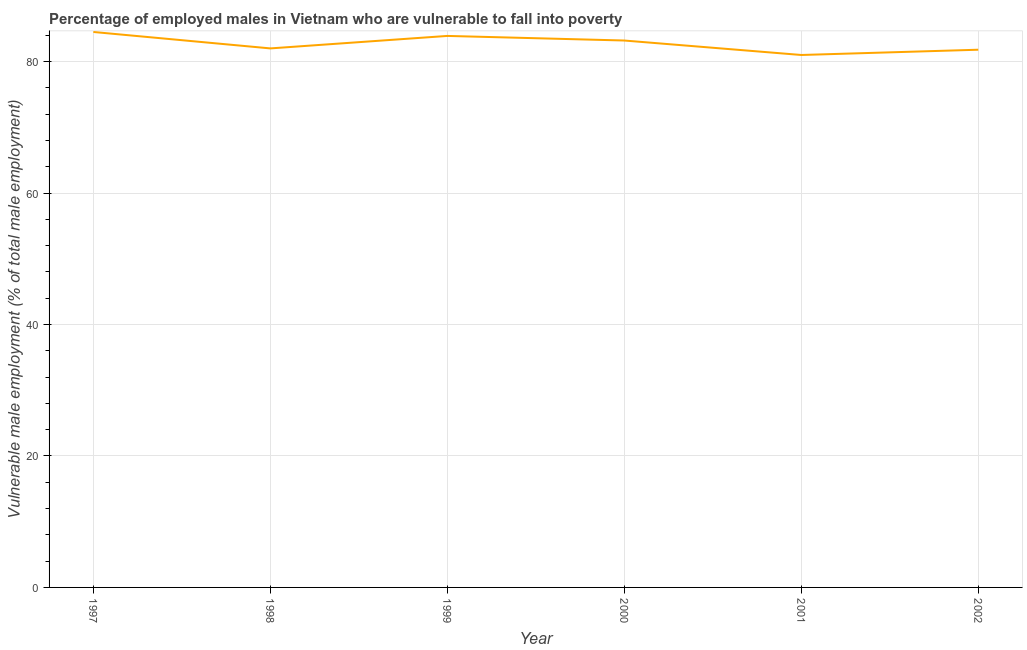What is the percentage of employed males who are vulnerable to fall into poverty in 1997?
Keep it short and to the point. 84.5. Across all years, what is the maximum percentage of employed males who are vulnerable to fall into poverty?
Keep it short and to the point. 84.5. Across all years, what is the minimum percentage of employed males who are vulnerable to fall into poverty?
Offer a very short reply. 81. What is the sum of the percentage of employed males who are vulnerable to fall into poverty?
Provide a succinct answer. 496.4. What is the difference between the percentage of employed males who are vulnerable to fall into poverty in 2001 and 2002?
Provide a succinct answer. -0.8. What is the average percentage of employed males who are vulnerable to fall into poverty per year?
Provide a short and direct response. 82.73. What is the median percentage of employed males who are vulnerable to fall into poverty?
Offer a terse response. 82.6. In how many years, is the percentage of employed males who are vulnerable to fall into poverty greater than 52 %?
Your response must be concise. 6. Do a majority of the years between 1999 and 2000 (inclusive) have percentage of employed males who are vulnerable to fall into poverty greater than 28 %?
Provide a succinct answer. Yes. What is the ratio of the percentage of employed males who are vulnerable to fall into poverty in 2000 to that in 2001?
Ensure brevity in your answer.  1.03. Is the percentage of employed males who are vulnerable to fall into poverty in 1997 less than that in 1999?
Ensure brevity in your answer.  No. Is the difference between the percentage of employed males who are vulnerable to fall into poverty in 2000 and 2002 greater than the difference between any two years?
Keep it short and to the point. No. What is the difference between the highest and the second highest percentage of employed males who are vulnerable to fall into poverty?
Your response must be concise. 0.6. Is the sum of the percentage of employed males who are vulnerable to fall into poverty in 1999 and 2002 greater than the maximum percentage of employed males who are vulnerable to fall into poverty across all years?
Offer a very short reply. Yes. In how many years, is the percentage of employed males who are vulnerable to fall into poverty greater than the average percentage of employed males who are vulnerable to fall into poverty taken over all years?
Make the answer very short. 3. Does the percentage of employed males who are vulnerable to fall into poverty monotonically increase over the years?
Offer a terse response. No. How many lines are there?
Offer a terse response. 1. How many years are there in the graph?
Offer a terse response. 6. Are the values on the major ticks of Y-axis written in scientific E-notation?
Your answer should be compact. No. Does the graph contain any zero values?
Give a very brief answer. No. What is the title of the graph?
Provide a succinct answer. Percentage of employed males in Vietnam who are vulnerable to fall into poverty. What is the label or title of the Y-axis?
Your answer should be compact. Vulnerable male employment (% of total male employment). What is the Vulnerable male employment (% of total male employment) in 1997?
Your answer should be compact. 84.5. What is the Vulnerable male employment (% of total male employment) of 1998?
Ensure brevity in your answer.  82. What is the Vulnerable male employment (% of total male employment) of 1999?
Give a very brief answer. 83.9. What is the Vulnerable male employment (% of total male employment) in 2000?
Your response must be concise. 83.2. What is the Vulnerable male employment (% of total male employment) of 2001?
Offer a terse response. 81. What is the Vulnerable male employment (% of total male employment) of 2002?
Provide a succinct answer. 81.8. What is the difference between the Vulnerable male employment (% of total male employment) in 1997 and 1999?
Make the answer very short. 0.6. What is the difference between the Vulnerable male employment (% of total male employment) in 1997 and 2000?
Offer a terse response. 1.3. What is the difference between the Vulnerable male employment (% of total male employment) in 1997 and 2001?
Give a very brief answer. 3.5. What is the difference between the Vulnerable male employment (% of total male employment) in 1997 and 2002?
Your answer should be very brief. 2.7. What is the difference between the Vulnerable male employment (% of total male employment) in 1998 and 1999?
Offer a terse response. -1.9. What is the difference between the Vulnerable male employment (% of total male employment) in 1998 and 2000?
Provide a short and direct response. -1.2. What is the difference between the Vulnerable male employment (% of total male employment) in 1998 and 2002?
Make the answer very short. 0.2. What is the difference between the Vulnerable male employment (% of total male employment) in 1999 and 2000?
Give a very brief answer. 0.7. What is the difference between the Vulnerable male employment (% of total male employment) in 1999 and 2001?
Provide a succinct answer. 2.9. What is the difference between the Vulnerable male employment (% of total male employment) in 1999 and 2002?
Provide a short and direct response. 2.1. What is the difference between the Vulnerable male employment (% of total male employment) in 2000 and 2001?
Keep it short and to the point. 2.2. What is the difference between the Vulnerable male employment (% of total male employment) in 2000 and 2002?
Offer a very short reply. 1.4. What is the difference between the Vulnerable male employment (% of total male employment) in 2001 and 2002?
Your answer should be compact. -0.8. What is the ratio of the Vulnerable male employment (% of total male employment) in 1997 to that in 2000?
Make the answer very short. 1.02. What is the ratio of the Vulnerable male employment (% of total male employment) in 1997 to that in 2001?
Offer a terse response. 1.04. What is the ratio of the Vulnerable male employment (% of total male employment) in 1997 to that in 2002?
Offer a terse response. 1.03. What is the ratio of the Vulnerable male employment (% of total male employment) in 1998 to that in 1999?
Offer a terse response. 0.98. What is the ratio of the Vulnerable male employment (% of total male employment) in 1998 to that in 2001?
Ensure brevity in your answer.  1.01. What is the ratio of the Vulnerable male employment (% of total male employment) in 1998 to that in 2002?
Your response must be concise. 1. What is the ratio of the Vulnerable male employment (% of total male employment) in 1999 to that in 2001?
Keep it short and to the point. 1.04. What is the ratio of the Vulnerable male employment (% of total male employment) in 1999 to that in 2002?
Provide a succinct answer. 1.03. What is the ratio of the Vulnerable male employment (% of total male employment) in 2001 to that in 2002?
Your answer should be compact. 0.99. 